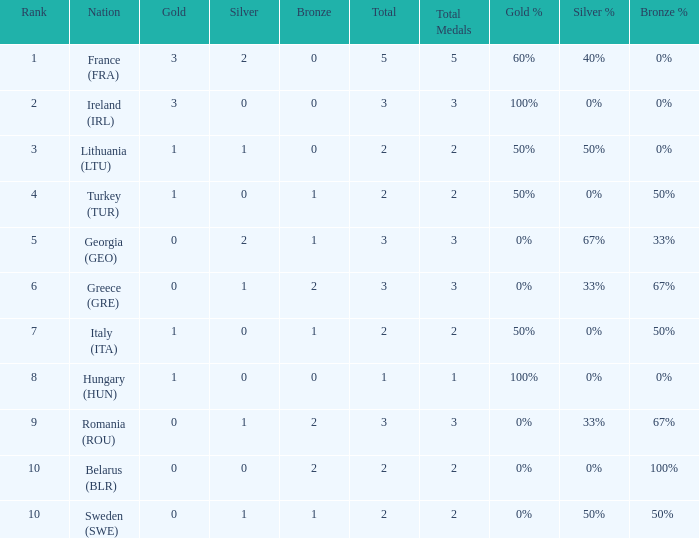Can you give me this table as a dict? {'header': ['Rank', 'Nation', 'Gold', 'Silver', 'Bronze', 'Total', 'Total Medals', 'Gold %', 'Silver %', 'Bronze %'], 'rows': [['1', 'France (FRA)', '3', '2', '0', '5', '5', '60%', '40%', '0%'], ['2', 'Ireland (IRL)', '3', '0', '0', '3', '3', '100%', '0%', '0%'], ['3', 'Lithuania (LTU)', '1', '1', '0', '2', '2', '50%', '50%', '0%'], ['4', 'Turkey (TUR)', '1', '0', '1', '2', '2', '50%', '0%', '50%'], ['5', 'Georgia (GEO)', '0', '2', '1', '3', '3', '0%', '67%', '33%'], ['6', 'Greece (GRE)', '0', '1', '2', '3', '3', '0%', '33%', '67%'], ['7', 'Italy (ITA)', '1', '0', '1', '2', '2', '50%', '0%', '50%'], ['8', 'Hungary (HUN)', '1', '0', '0', '1', '1', '100%', '0%', '0%'], ['9', 'Romania (ROU)', '0', '1', '2', '3', '3', '0%', '33%', '67%'], ['10', 'Belarus (BLR)', '0', '0', '2', '2', '2', '0%', '0%', '100%'], ['10', 'Sweden (SWE)', '0', '1', '1', '2', '2', '0%', '50%', '50% ']]} What's the total number of bronze medals for Sweden (SWE) having less than 1 gold and silver? 0.0. 